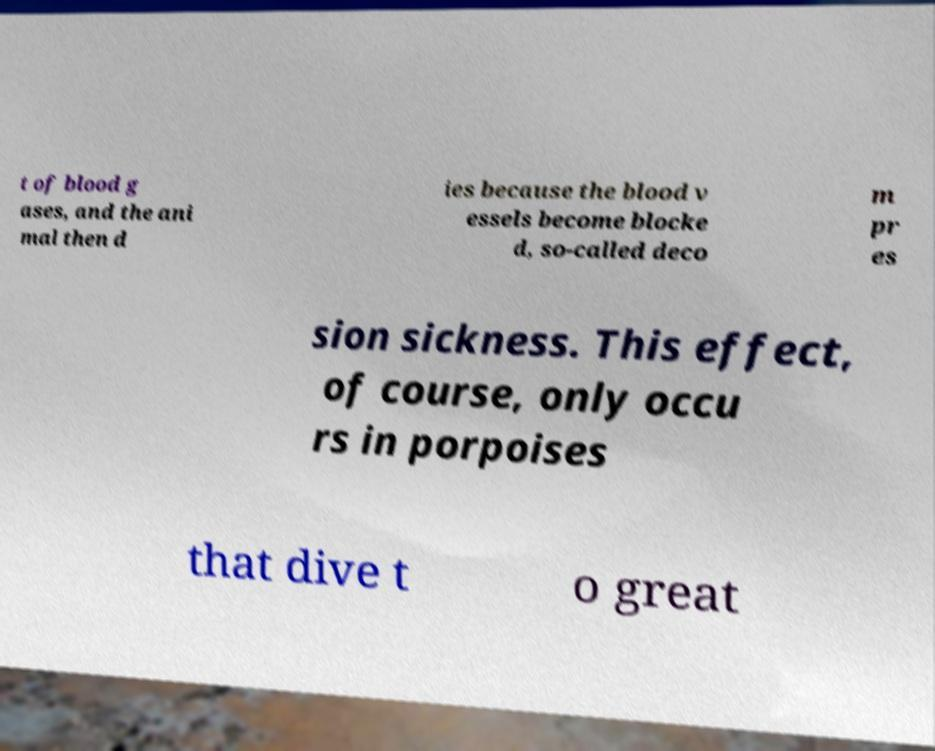Could you assist in decoding the text presented in this image and type it out clearly? t of blood g ases, and the ani mal then d ies because the blood v essels become blocke d, so-called deco m pr es sion sickness. This effect, of course, only occu rs in porpoises that dive t o great 